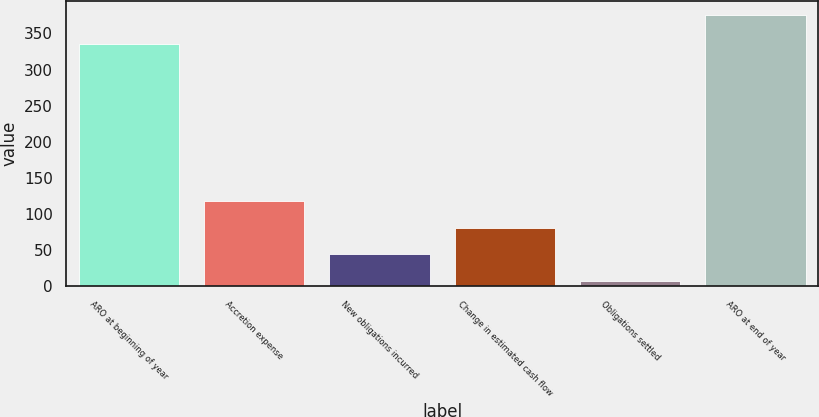Convert chart to OTSL. <chart><loc_0><loc_0><loc_500><loc_500><bar_chart><fcel>ARO at beginning of year<fcel>Accretion expense<fcel>New obligations incurred<fcel>Change in estimated cash flow<fcel>Obligations settled<fcel>ARO at end of year<nl><fcel>336<fcel>117.7<fcel>43.9<fcel>80.8<fcel>7<fcel>376<nl></chart> 